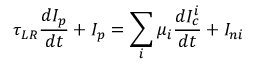<formula> <loc_0><loc_0><loc_500><loc_500>\tau _ { L R } \frac { d I _ { p } } { d t } + I _ { p } = \sum _ { i } \mu _ { i } \frac { d I _ { c } ^ { i } } { d t } + I _ { n i }</formula> 